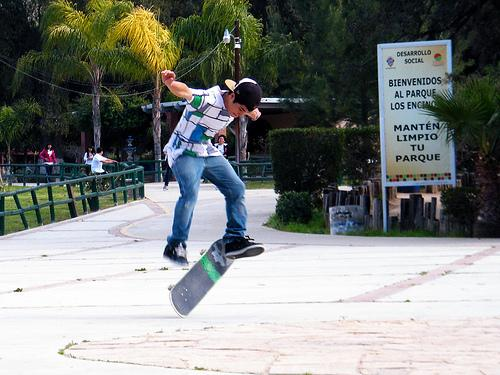What are some noticeable features of the skateboard in this image? The skateboard is black with a white skull design on it, and it's in the air during the boy's trick. How would you describe the environment surrounding the boy? The boy is surrounded by a street with a green fence bordering a cement area, bushes, and power lines behind him. Name at least three objects in the background of the image. A tall sign printed in Spanish, a street light, and a palm tree. How many people are there in the image and what are they wearing? There are three people in the image, one wearing a red shirt, one wearing a white shirt, and the boy in white patterned shirt. Analyze the positioning of the boy's body during his skateboard trick. The boy's legs are apart, and his hand is raised while he jumps and hovers in the air with the skateboard. Briefly describe the color and style of the boy's hat and shirt. The boy's hat is black and yellow, worn backward, and his shirt is white with blue and green designs. Can you list the components of the boy's outfit? The boy is wearing a black baseball cap backwards, a white patterned shirt, blue jeans, and black shoes. What is the overall emotion or sentiment portrayed in this image? The overall sentiment portrayed is excitement and thrill as the boy performs a challenging skateboard trick. What is the primary action being performed by the subject in this image? A young boy is performing a skateboard trick while being airborne. Using simple language, describe the most interesting part of the image. The boy wearing a hat is jumping high on his cool skateboard with a skull on it, doing a trick. Is the skateboard pink with a yellow star design on it? No, it's not mentioned in the image. Do you see a person wearing a bright green hat? There is no one in the image wearing a bright green hat. The boy is wearing a black baseball cap backwards. The instruction is misleading because it describes a nonexistent object in the image. Can you spot the boy wearing a red shirt and blue jeans? There is a person in a red shirt, but they are not the same person as the boy wearing blue jeans. The boy is wearing a white patterned shirt, blue jeans, and a black baseball cap backwards. The person in the red shirt is a separate object in the image. Can you find a dog sitting next to the skateboard? There is no dog in this image. All the objects described in the list are related to the people, objects or surroundings, and there is no mention of a dog. This instruction is misleading because it refers to a nonexistent object in the image. Is there a blue fence bordering the cement? There is a green fence bordering the cement in the image, not a blue one. This instruction is misleading because it gives the wrong color for the fence. Can you find the palm tree with purple leaves beside the boy? There is a palm tree in the image, but it is located by the sign, not beside the boy. Also, the palm tree has green leaves, not purple ones. The instruction is misleading because of the wrong location and leaf color. 